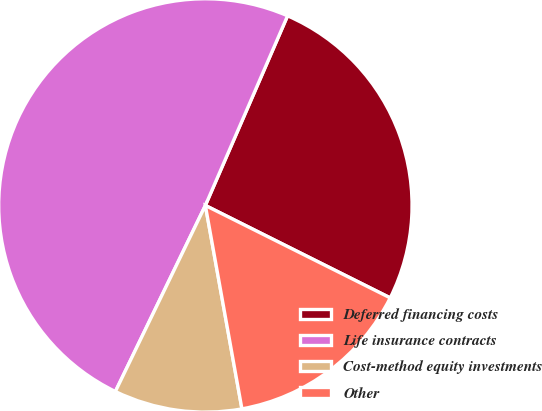Convert chart to OTSL. <chart><loc_0><loc_0><loc_500><loc_500><pie_chart><fcel>Deferred financing costs<fcel>Life insurance contracts<fcel>Cost-method equity investments<fcel>Other<nl><fcel>25.87%<fcel>49.34%<fcel>10.0%<fcel>14.79%<nl></chart> 